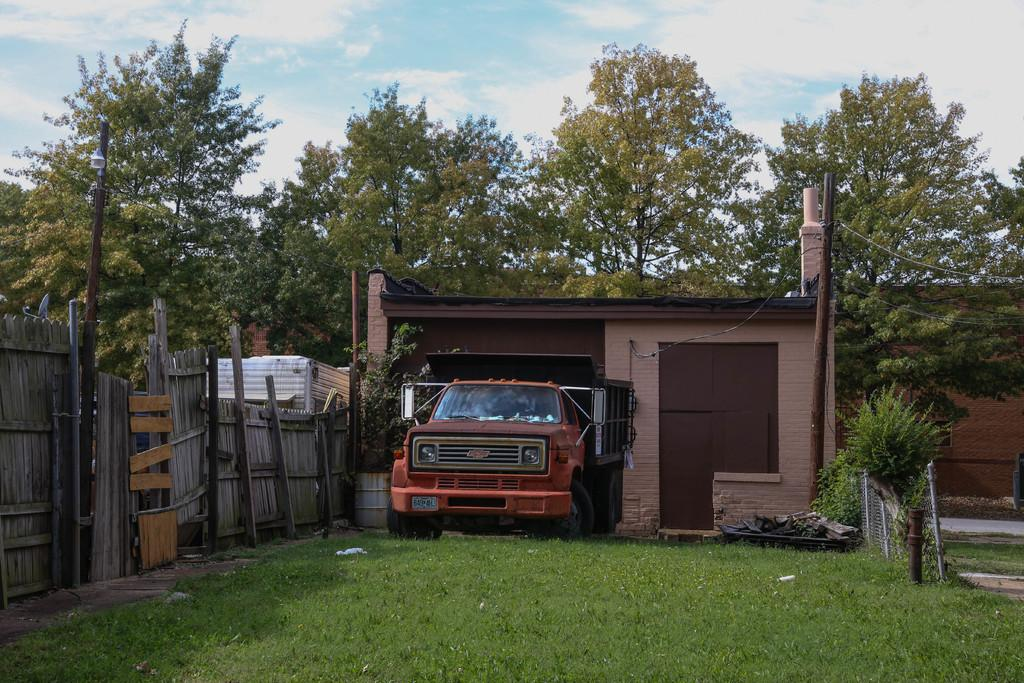What is the main subject in the middle of the image? There is a truck in the middle of the image. Where is the truck located? The truck is on the grass. What can be seen in the background of the image? There are trees, cables, and clouds visible in the background of the image. What is on the right side of the image? There is a fence on the right side of the image. What book is the truck reading in the image? Trucks do not read books, as they are inanimate objects. 